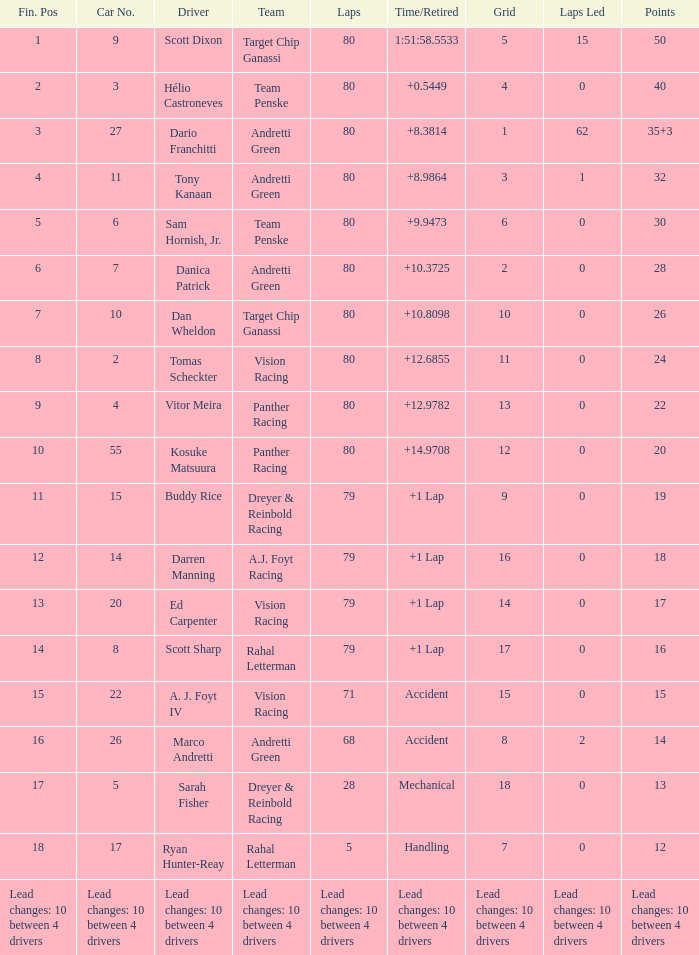Which squad has 26 points? Target Chip Ganassi. 